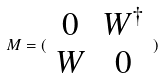<formula> <loc_0><loc_0><loc_500><loc_500>M = ( \begin{array} { c c } 0 & W ^ { \dagger } \\ W & 0 \end{array} )</formula> 